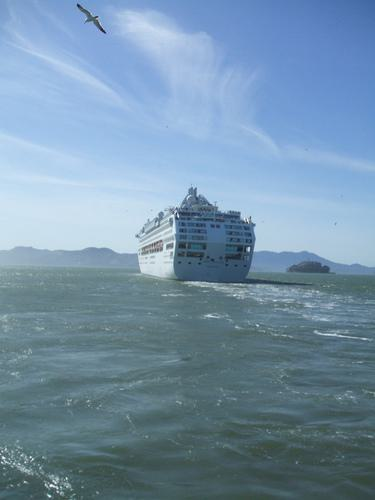What activities might passengers be enjoying on this cruise ship? Passengers on the cruise ship might be indulging in a variety of activities, from lounging by the pool, enjoying gourmet meals at the ship's restaurants, participating in onboard entertainment such as live shows or casinos, to simply admiring the panoramic ocean views from their private balconies or the ship's decks. 